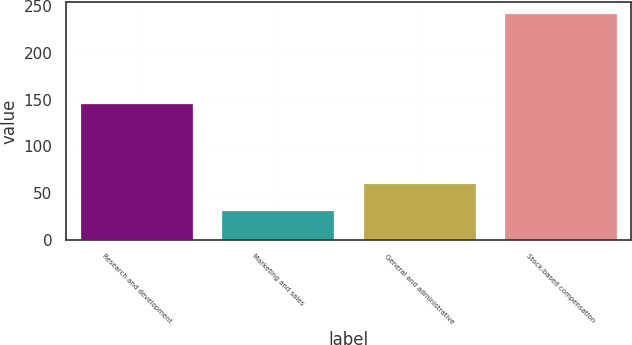Convert chart. <chart><loc_0><loc_0><loc_500><loc_500><bar_chart><fcel>Research and development<fcel>Marketing and sales<fcel>General and administrative<fcel>Stock-based compensation<nl><fcel>146<fcel>32<fcel>61<fcel>242<nl></chart> 